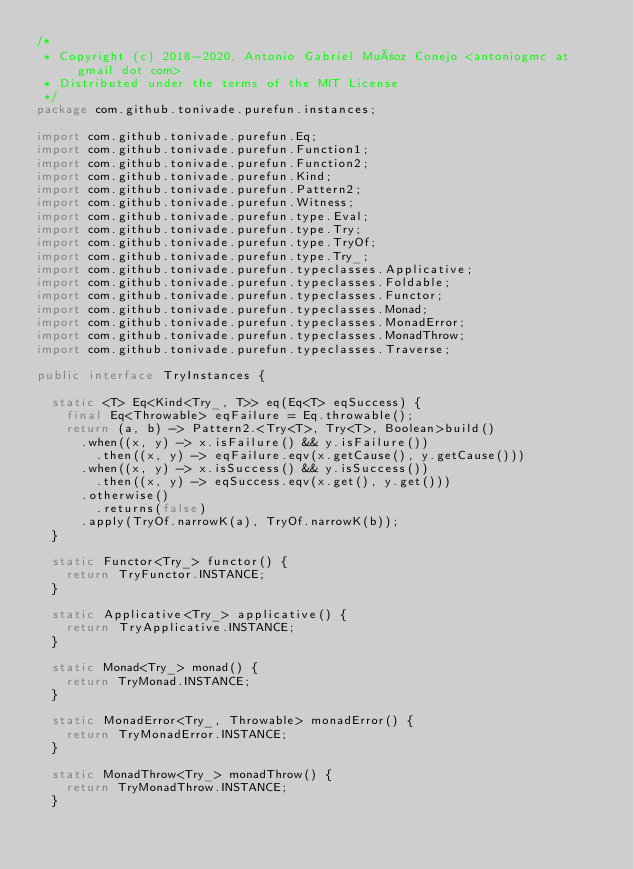<code> <loc_0><loc_0><loc_500><loc_500><_Java_>/*
 * Copyright (c) 2018-2020, Antonio Gabriel Muñoz Conejo <antoniogmc at gmail dot com>
 * Distributed under the terms of the MIT License
 */
package com.github.tonivade.purefun.instances;

import com.github.tonivade.purefun.Eq;
import com.github.tonivade.purefun.Function1;
import com.github.tonivade.purefun.Function2;
import com.github.tonivade.purefun.Kind;
import com.github.tonivade.purefun.Pattern2;
import com.github.tonivade.purefun.Witness;
import com.github.tonivade.purefun.type.Eval;
import com.github.tonivade.purefun.type.Try;
import com.github.tonivade.purefun.type.TryOf;
import com.github.tonivade.purefun.type.Try_;
import com.github.tonivade.purefun.typeclasses.Applicative;
import com.github.tonivade.purefun.typeclasses.Foldable;
import com.github.tonivade.purefun.typeclasses.Functor;
import com.github.tonivade.purefun.typeclasses.Monad;
import com.github.tonivade.purefun.typeclasses.MonadError;
import com.github.tonivade.purefun.typeclasses.MonadThrow;
import com.github.tonivade.purefun.typeclasses.Traverse;

public interface TryInstances {

  static <T> Eq<Kind<Try_, T>> eq(Eq<T> eqSuccess) {
    final Eq<Throwable> eqFailure = Eq.throwable();
    return (a, b) -> Pattern2.<Try<T>, Try<T>, Boolean>build()
      .when((x, y) -> x.isFailure() && y.isFailure())
        .then((x, y) -> eqFailure.eqv(x.getCause(), y.getCause()))
      .when((x, y) -> x.isSuccess() && y.isSuccess())
        .then((x, y) -> eqSuccess.eqv(x.get(), y.get()))
      .otherwise()
        .returns(false)
      .apply(TryOf.narrowK(a), TryOf.narrowK(b));
  }

  static Functor<Try_> functor() {
    return TryFunctor.INSTANCE;
  }

  static Applicative<Try_> applicative() {
    return TryApplicative.INSTANCE;
  }

  static Monad<Try_> monad() {
    return TryMonad.INSTANCE;
  }

  static MonadError<Try_, Throwable> monadError() {
    return TryMonadError.INSTANCE;
  }

  static MonadThrow<Try_> monadThrow() {
    return TryMonadThrow.INSTANCE;
  }
</code> 